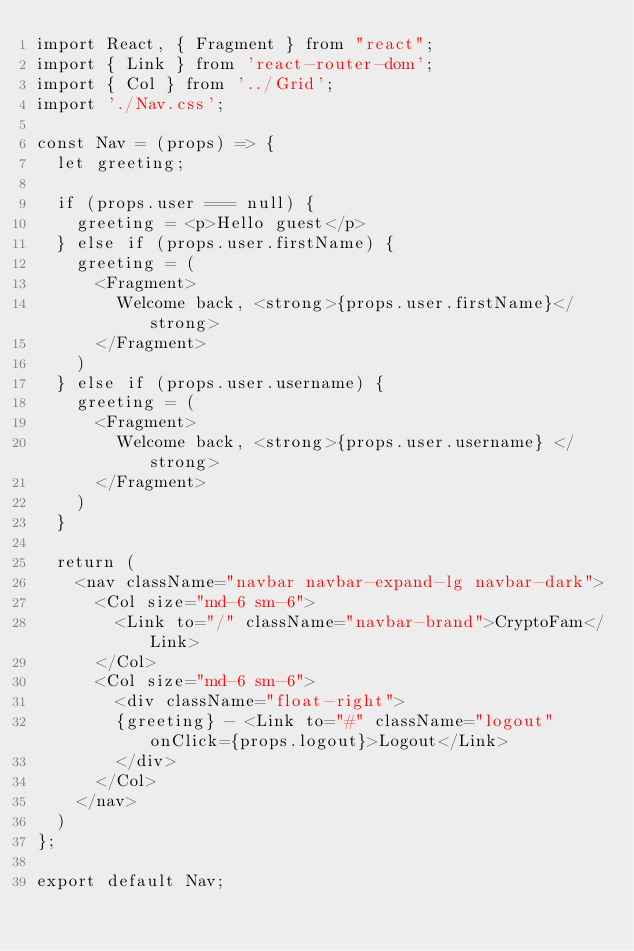Convert code to text. <code><loc_0><loc_0><loc_500><loc_500><_JavaScript_>import React, { Fragment } from "react";
import { Link } from 'react-router-dom';
import { Col } from '../Grid';
import './Nav.css';

const Nav = (props) => {
  let greeting;

  if (props.user === null) {
		greeting = <p>Hello guest</p>
	} else if (props.user.firstName) {
		greeting = (
			<Fragment>
				Welcome back, <strong>{props.user.firstName}</strong>
			</Fragment>
		)
	} else if (props.user.username) {
		greeting = (
			<Fragment>
				Welcome back, <strong>{props.user.username} </strong>
			</Fragment>
		)
  }
  
  return (
    <nav className="navbar navbar-expand-lg navbar-dark">
      <Col size="md-6 sm-6">
        <Link to="/" className="navbar-brand">CryptoFam</Link>
      </Col>
      <Col size="md-6 sm-6">
        <div className="float-right">
        {greeting} - <Link to="#" className="logout" onClick={props.logout}>Logout</Link>
        </div>
      </Col>
    </nav>
  )
};

export default Nav;
</code> 